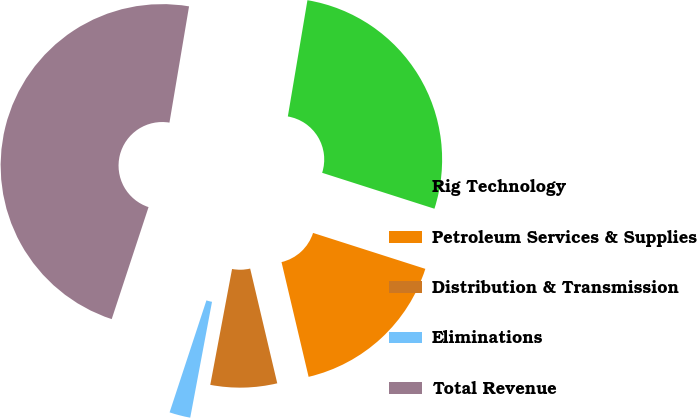Convert chart. <chart><loc_0><loc_0><loc_500><loc_500><pie_chart><fcel>Rig Technology<fcel>Petroleum Services & Supplies<fcel>Distribution & Transmission<fcel>Eliminations<fcel>Total Revenue<nl><fcel>27.27%<fcel>16.38%<fcel>6.65%<fcel>2.1%<fcel>47.6%<nl></chart> 